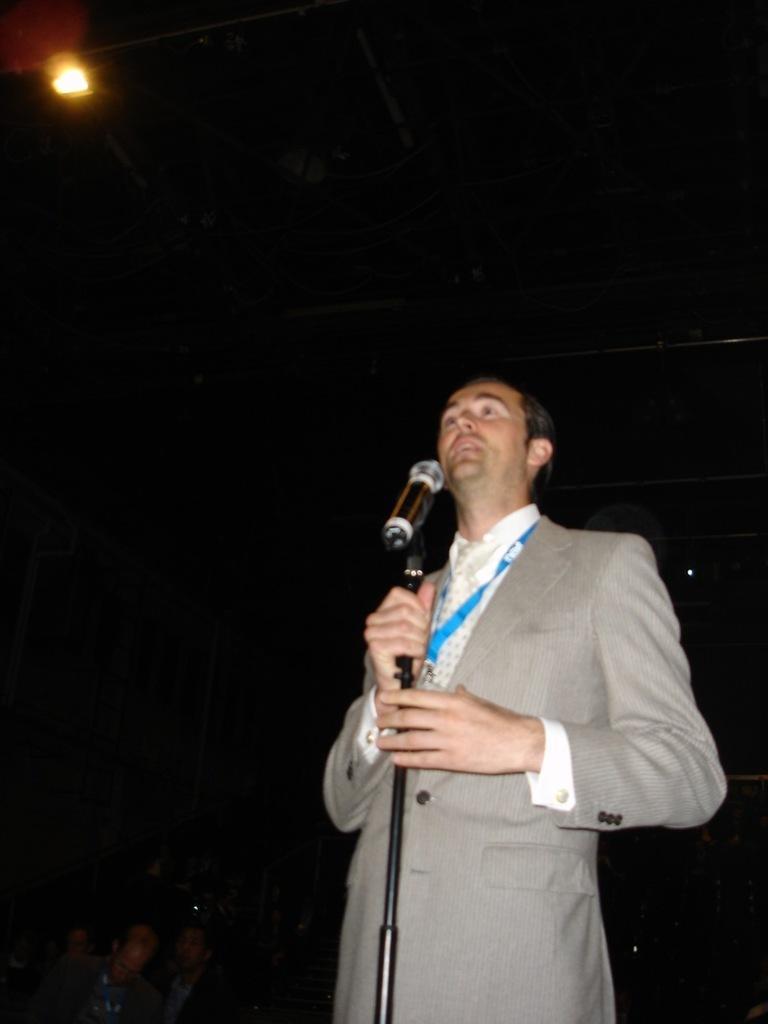In one or two sentences, can you explain what this image depicts? This is an image clicked in the dark. Here I can see a man wearing jacket, standing and holding mike stand in hands. It seems like he is singing. At the bottom of the image I can see few people in the dark. On the top left of the image there is a light. 